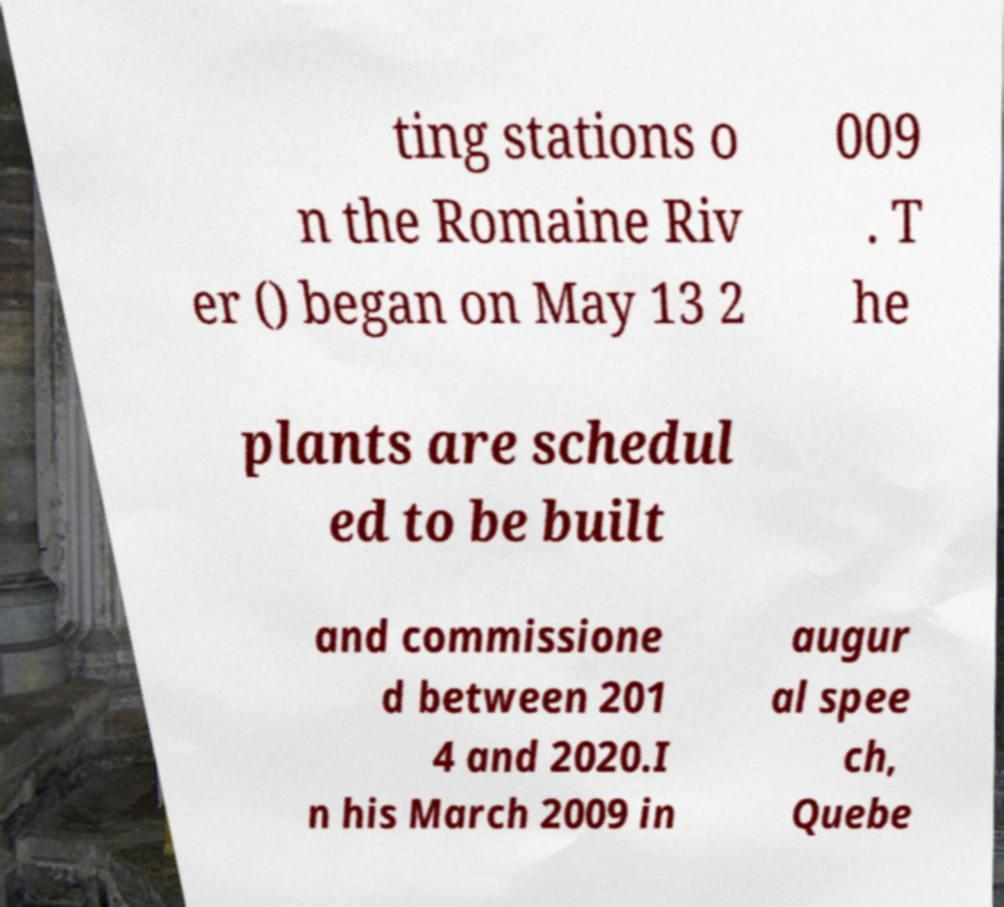Could you assist in decoding the text presented in this image and type it out clearly? ting stations o n the Romaine Riv er () began on May 13 2 009 . T he plants are schedul ed to be built and commissione d between 201 4 and 2020.I n his March 2009 in augur al spee ch, Quebe 